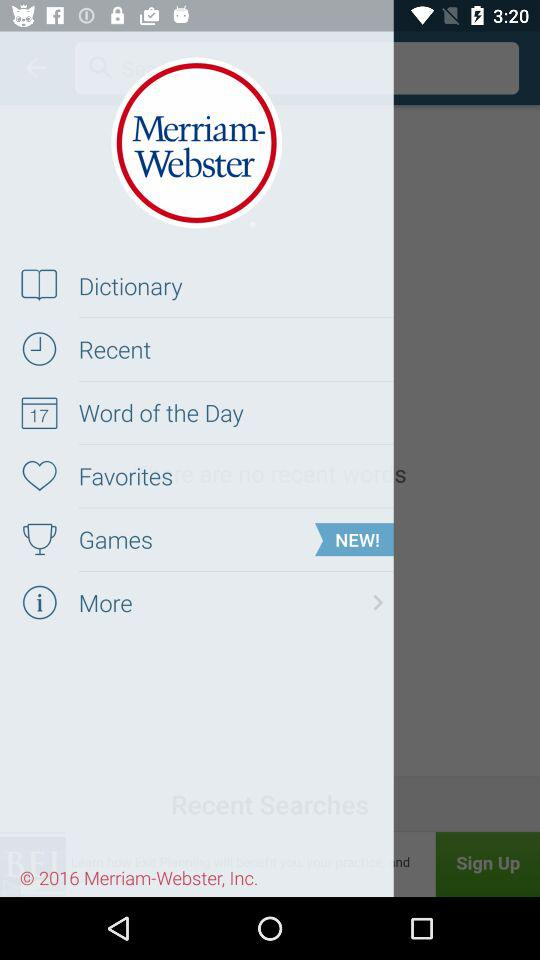What is the application name? The application name is "Dictionary - Merriam-Webster". 